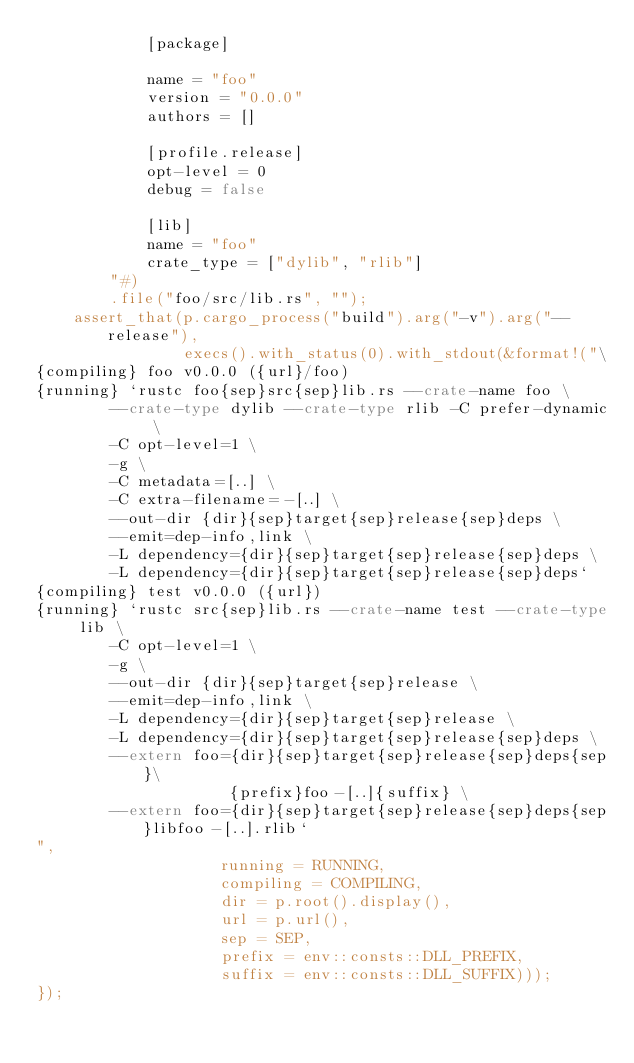<code> <loc_0><loc_0><loc_500><loc_500><_Rust_>            [package]

            name = "foo"
            version = "0.0.0"
            authors = []

            [profile.release]
            opt-level = 0
            debug = false

            [lib]
            name = "foo"
            crate_type = ["dylib", "rlib"]
        "#)
        .file("foo/src/lib.rs", "");
    assert_that(p.cargo_process("build").arg("-v").arg("--release"),
                execs().with_status(0).with_stdout(&format!("\
{compiling} foo v0.0.0 ({url}/foo)
{running} `rustc foo{sep}src{sep}lib.rs --crate-name foo \
        --crate-type dylib --crate-type rlib -C prefer-dynamic \
        -C opt-level=1 \
        -g \
        -C metadata=[..] \
        -C extra-filename=-[..] \
        --out-dir {dir}{sep}target{sep}release{sep}deps \
        --emit=dep-info,link \
        -L dependency={dir}{sep}target{sep}release{sep}deps \
        -L dependency={dir}{sep}target{sep}release{sep}deps`
{compiling} test v0.0.0 ({url})
{running} `rustc src{sep}lib.rs --crate-name test --crate-type lib \
        -C opt-level=1 \
        -g \
        --out-dir {dir}{sep}target{sep}release \
        --emit=dep-info,link \
        -L dependency={dir}{sep}target{sep}release \
        -L dependency={dir}{sep}target{sep}release{sep}deps \
        --extern foo={dir}{sep}target{sep}release{sep}deps{sep}\
                     {prefix}foo-[..]{suffix} \
        --extern foo={dir}{sep}target{sep}release{sep}deps{sep}libfoo-[..].rlib`
",
                    running = RUNNING,
                    compiling = COMPILING,
                    dir = p.root().display(),
                    url = p.url(),
                    sep = SEP,
                    prefix = env::consts::DLL_PREFIX,
                    suffix = env::consts::DLL_SUFFIX)));
});
</code> 